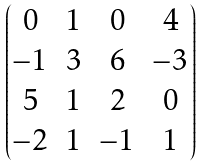<formula> <loc_0><loc_0><loc_500><loc_500>\begin{pmatrix} 0 & 1 & 0 & 4 \\ - 1 & 3 & 6 & - 3 \\ 5 & 1 & 2 & 0 \\ - 2 & 1 & - 1 & 1 \end{pmatrix}</formula> 